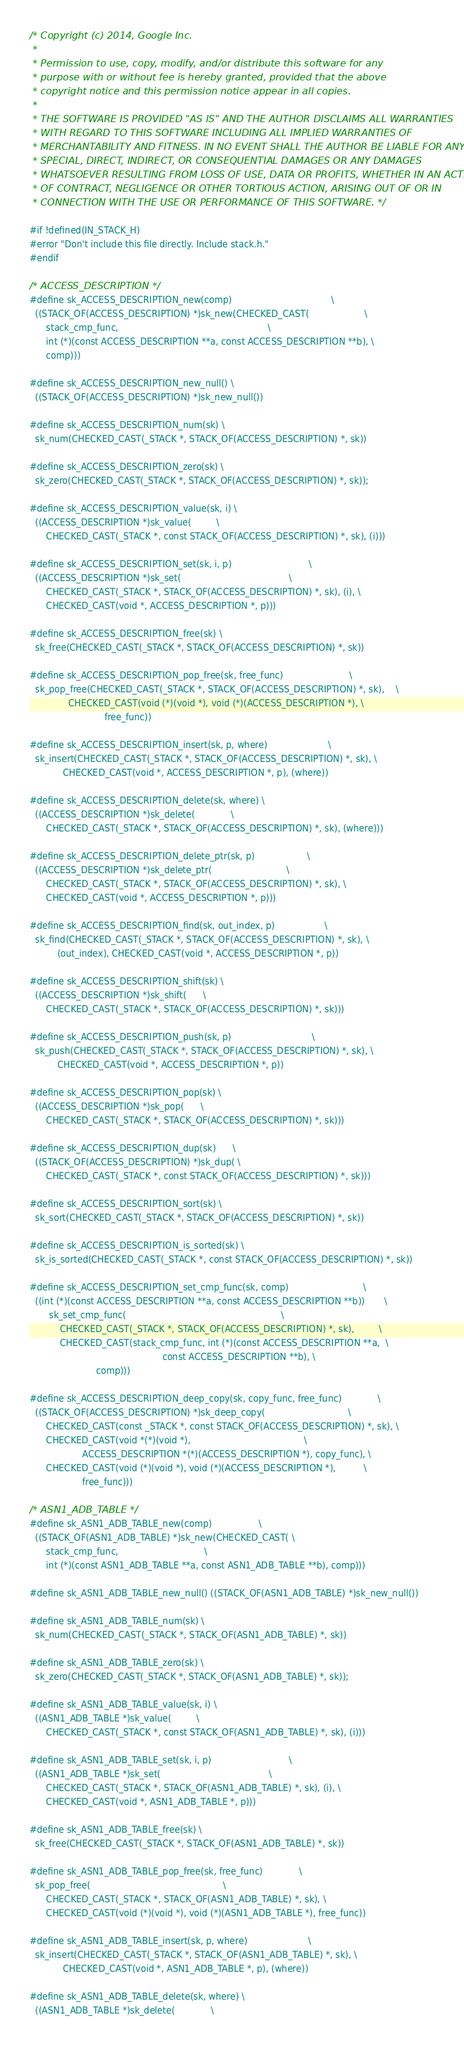<code> <loc_0><loc_0><loc_500><loc_500><_C_>/* Copyright (c) 2014, Google Inc.
 *
 * Permission to use, copy, modify, and/or distribute this software for any
 * purpose with or without fee is hereby granted, provided that the above
 * copyright notice and this permission notice appear in all copies.
 *
 * THE SOFTWARE IS PROVIDED "AS IS" AND THE AUTHOR DISCLAIMS ALL WARRANTIES
 * WITH REGARD TO THIS SOFTWARE INCLUDING ALL IMPLIED WARRANTIES OF
 * MERCHANTABILITY AND FITNESS. IN NO EVENT SHALL THE AUTHOR BE LIABLE FOR ANY
 * SPECIAL, DIRECT, INDIRECT, OR CONSEQUENTIAL DAMAGES OR ANY DAMAGES
 * WHATSOEVER RESULTING FROM LOSS OF USE, DATA OR PROFITS, WHETHER IN AN ACTION
 * OF CONTRACT, NEGLIGENCE OR OTHER TORTIOUS ACTION, ARISING OUT OF OR IN
 * CONNECTION WITH THE USE OR PERFORMANCE OF THIS SOFTWARE. */

#if !defined(IN_STACK_H)
#error "Don't include this file directly. Include stack.h."
#endif

/* ACCESS_DESCRIPTION */
#define sk_ACCESS_DESCRIPTION_new(comp)                                    \
  ((STACK_OF(ACCESS_DESCRIPTION) *)sk_new(CHECKED_CAST(                    \
      stack_cmp_func,                                                      \
      int (*)(const ACCESS_DESCRIPTION **a, const ACCESS_DESCRIPTION **b), \
      comp)))

#define sk_ACCESS_DESCRIPTION_new_null() \
  ((STACK_OF(ACCESS_DESCRIPTION) *)sk_new_null())

#define sk_ACCESS_DESCRIPTION_num(sk) \
  sk_num(CHECKED_CAST(_STACK *, STACK_OF(ACCESS_DESCRIPTION) *, sk))

#define sk_ACCESS_DESCRIPTION_zero(sk) \
  sk_zero(CHECKED_CAST(_STACK *, STACK_OF(ACCESS_DESCRIPTION) *, sk));

#define sk_ACCESS_DESCRIPTION_value(sk, i) \
  ((ACCESS_DESCRIPTION *)sk_value(         \
      CHECKED_CAST(_STACK *, const STACK_OF(ACCESS_DESCRIPTION) *, sk), (i)))

#define sk_ACCESS_DESCRIPTION_set(sk, i, p)                            \
  ((ACCESS_DESCRIPTION *)sk_set(                                       \
      CHECKED_CAST(_STACK *, STACK_OF(ACCESS_DESCRIPTION) *, sk), (i), \
      CHECKED_CAST(void *, ACCESS_DESCRIPTION *, p)))

#define sk_ACCESS_DESCRIPTION_free(sk) \
  sk_free(CHECKED_CAST(_STACK *, STACK_OF(ACCESS_DESCRIPTION) *, sk))

#define sk_ACCESS_DESCRIPTION_pop_free(sk, free_func)                        \
  sk_pop_free(CHECKED_CAST(_STACK *, STACK_OF(ACCESS_DESCRIPTION) *, sk),    \
              CHECKED_CAST(void (*)(void *), void (*)(ACCESS_DESCRIPTION *), \
                           free_func))

#define sk_ACCESS_DESCRIPTION_insert(sk, p, where)                      \
  sk_insert(CHECKED_CAST(_STACK *, STACK_OF(ACCESS_DESCRIPTION) *, sk), \
            CHECKED_CAST(void *, ACCESS_DESCRIPTION *, p), (where))

#define sk_ACCESS_DESCRIPTION_delete(sk, where) \
  ((ACCESS_DESCRIPTION *)sk_delete(             \
      CHECKED_CAST(_STACK *, STACK_OF(ACCESS_DESCRIPTION) *, sk), (where)))

#define sk_ACCESS_DESCRIPTION_delete_ptr(sk, p)                   \
  ((ACCESS_DESCRIPTION *)sk_delete_ptr(                           \
      CHECKED_CAST(_STACK *, STACK_OF(ACCESS_DESCRIPTION) *, sk), \
      CHECKED_CAST(void *, ACCESS_DESCRIPTION *, p)))

#define sk_ACCESS_DESCRIPTION_find(sk, out_index, p)                  \
  sk_find(CHECKED_CAST(_STACK *, STACK_OF(ACCESS_DESCRIPTION) *, sk), \
          (out_index), CHECKED_CAST(void *, ACCESS_DESCRIPTION *, p))

#define sk_ACCESS_DESCRIPTION_shift(sk) \
  ((ACCESS_DESCRIPTION *)sk_shift(      \
      CHECKED_CAST(_STACK *, STACK_OF(ACCESS_DESCRIPTION) *, sk)))

#define sk_ACCESS_DESCRIPTION_push(sk, p)                             \
  sk_push(CHECKED_CAST(_STACK *, STACK_OF(ACCESS_DESCRIPTION) *, sk), \
          CHECKED_CAST(void *, ACCESS_DESCRIPTION *, p))

#define sk_ACCESS_DESCRIPTION_pop(sk) \
  ((ACCESS_DESCRIPTION *)sk_pop(      \
      CHECKED_CAST(_STACK *, STACK_OF(ACCESS_DESCRIPTION) *, sk)))

#define sk_ACCESS_DESCRIPTION_dup(sk)      \
  ((STACK_OF(ACCESS_DESCRIPTION) *)sk_dup( \
      CHECKED_CAST(_STACK *, const STACK_OF(ACCESS_DESCRIPTION) *, sk)))

#define sk_ACCESS_DESCRIPTION_sort(sk) \
  sk_sort(CHECKED_CAST(_STACK *, STACK_OF(ACCESS_DESCRIPTION) *, sk))

#define sk_ACCESS_DESCRIPTION_is_sorted(sk) \
  sk_is_sorted(CHECKED_CAST(_STACK *, const STACK_OF(ACCESS_DESCRIPTION) *, sk))

#define sk_ACCESS_DESCRIPTION_set_cmp_func(sk, comp)                           \
  ((int (*)(const ACCESS_DESCRIPTION **a, const ACCESS_DESCRIPTION **b))       \
       sk_set_cmp_func(                                                        \
           CHECKED_CAST(_STACK *, STACK_OF(ACCESS_DESCRIPTION) *, sk),         \
           CHECKED_CAST(stack_cmp_func, int (*)(const ACCESS_DESCRIPTION **a,  \
                                                const ACCESS_DESCRIPTION **b), \
                        comp)))

#define sk_ACCESS_DESCRIPTION_deep_copy(sk, copy_func, free_func)             \
  ((STACK_OF(ACCESS_DESCRIPTION) *)sk_deep_copy(                              \
      CHECKED_CAST(const _STACK *, const STACK_OF(ACCESS_DESCRIPTION) *, sk), \
      CHECKED_CAST(void *(*)(void *),                                         \
                   ACCESS_DESCRIPTION *(*)(ACCESS_DESCRIPTION *), copy_func), \
      CHECKED_CAST(void (*)(void *), void (*)(ACCESS_DESCRIPTION *),          \
                   free_func)))

/* ASN1_ADB_TABLE */
#define sk_ASN1_ADB_TABLE_new(comp)                 \
  ((STACK_OF(ASN1_ADB_TABLE) *)sk_new(CHECKED_CAST( \
      stack_cmp_func,                               \
      int (*)(const ASN1_ADB_TABLE **a, const ASN1_ADB_TABLE **b), comp)))

#define sk_ASN1_ADB_TABLE_new_null() ((STACK_OF(ASN1_ADB_TABLE) *)sk_new_null())

#define sk_ASN1_ADB_TABLE_num(sk) \
  sk_num(CHECKED_CAST(_STACK *, STACK_OF(ASN1_ADB_TABLE) *, sk))

#define sk_ASN1_ADB_TABLE_zero(sk) \
  sk_zero(CHECKED_CAST(_STACK *, STACK_OF(ASN1_ADB_TABLE) *, sk));

#define sk_ASN1_ADB_TABLE_value(sk, i) \
  ((ASN1_ADB_TABLE *)sk_value(         \
      CHECKED_CAST(_STACK *, const STACK_OF(ASN1_ADB_TABLE) *, sk), (i)))

#define sk_ASN1_ADB_TABLE_set(sk, i, p)                            \
  ((ASN1_ADB_TABLE *)sk_set(                                       \
      CHECKED_CAST(_STACK *, STACK_OF(ASN1_ADB_TABLE) *, sk), (i), \
      CHECKED_CAST(void *, ASN1_ADB_TABLE *, p)))

#define sk_ASN1_ADB_TABLE_free(sk) \
  sk_free(CHECKED_CAST(_STACK *, STACK_OF(ASN1_ADB_TABLE) *, sk))

#define sk_ASN1_ADB_TABLE_pop_free(sk, free_func)             \
  sk_pop_free(                                                \
      CHECKED_CAST(_STACK *, STACK_OF(ASN1_ADB_TABLE) *, sk), \
      CHECKED_CAST(void (*)(void *), void (*)(ASN1_ADB_TABLE *), free_func))

#define sk_ASN1_ADB_TABLE_insert(sk, p, where)                      \
  sk_insert(CHECKED_CAST(_STACK *, STACK_OF(ASN1_ADB_TABLE) *, sk), \
            CHECKED_CAST(void *, ASN1_ADB_TABLE *, p), (where))

#define sk_ASN1_ADB_TABLE_delete(sk, where) \
  ((ASN1_ADB_TABLE *)sk_delete(             \</code> 